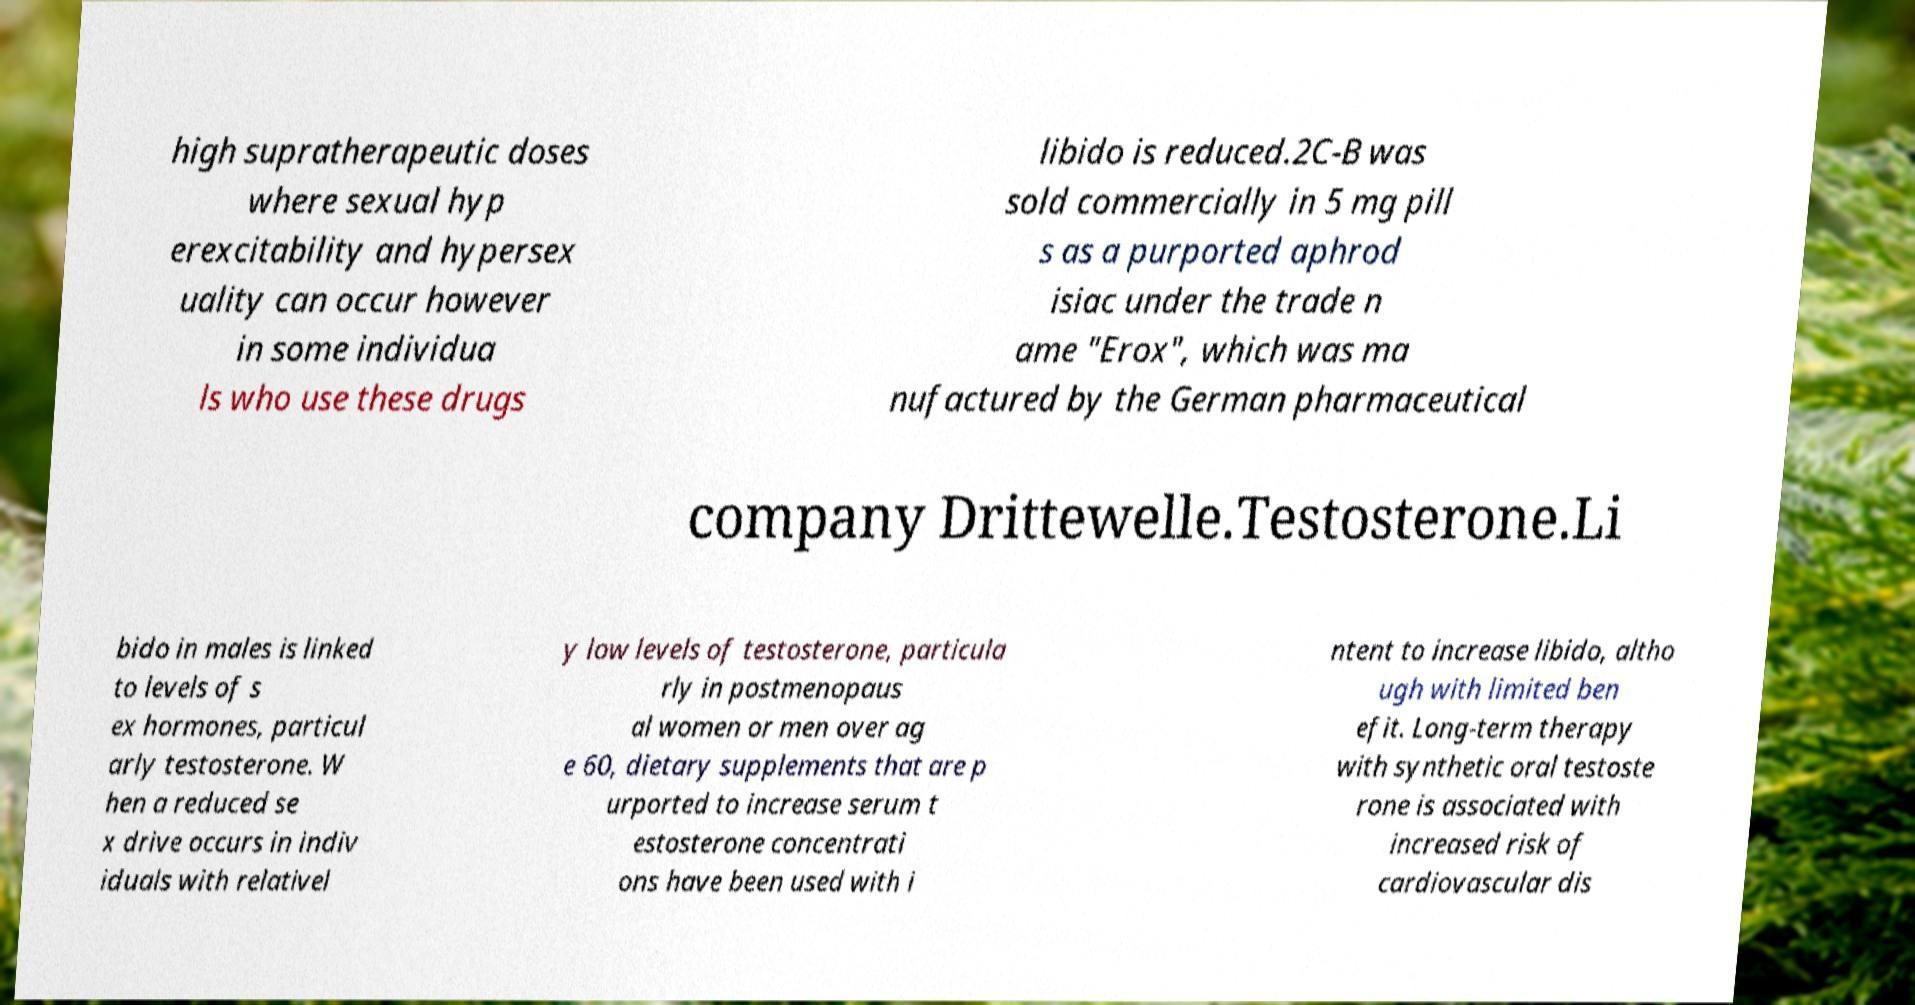I need the written content from this picture converted into text. Can you do that? high supratherapeutic doses where sexual hyp erexcitability and hypersex uality can occur however in some individua ls who use these drugs libido is reduced.2C-B was sold commercially in 5 mg pill s as a purported aphrod isiac under the trade n ame "Erox", which was ma nufactured by the German pharmaceutical company Drittewelle.Testosterone.Li bido in males is linked to levels of s ex hormones, particul arly testosterone. W hen a reduced se x drive occurs in indiv iduals with relativel y low levels of testosterone, particula rly in postmenopaus al women or men over ag e 60, dietary supplements that are p urported to increase serum t estosterone concentrati ons have been used with i ntent to increase libido, altho ugh with limited ben efit. Long-term therapy with synthetic oral testoste rone is associated with increased risk of cardiovascular dis 